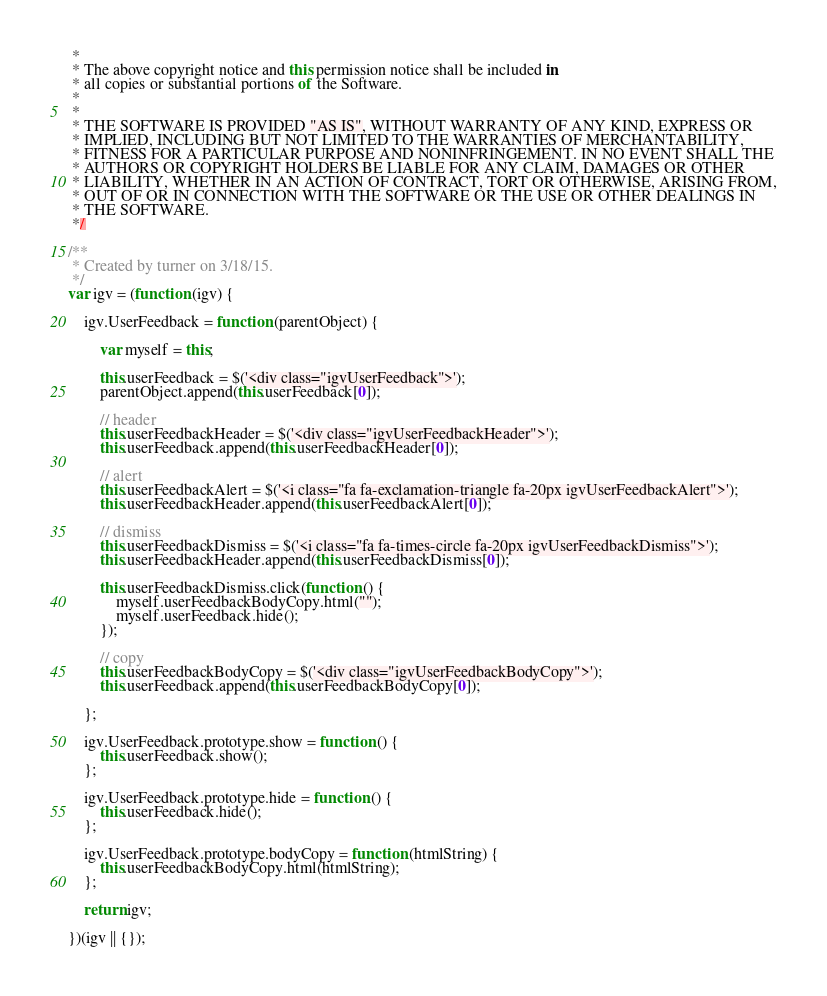Convert code to text. <code><loc_0><loc_0><loc_500><loc_500><_JavaScript_> *
 * The above copyright notice and this permission notice shall be included in
 * all copies or substantial portions of the Software.
 *
 *
 * THE SOFTWARE IS PROVIDED "AS IS", WITHOUT WARRANTY OF ANY KIND, EXPRESS OR
 * IMPLIED, INCLUDING BUT NOT LIMITED TO THE WARRANTIES OF MERCHANTABILITY,
 * FITNESS FOR A PARTICULAR PURPOSE AND NONINFRINGEMENT. IN NO EVENT SHALL THE
 * AUTHORS OR COPYRIGHT HOLDERS BE LIABLE FOR ANY CLAIM, DAMAGES OR OTHER
 * LIABILITY, WHETHER IN AN ACTION OF CONTRACT, TORT OR OTHERWISE, ARISING FROM,
 * OUT OF OR IN CONNECTION WITH THE SOFTWARE OR THE USE OR OTHER DEALINGS IN
 * THE SOFTWARE.
 */

/**
 * Created by turner on 3/18/15.
 */
var igv = (function (igv) {

    igv.UserFeedback = function (parentObject) {

        var myself = this;

        this.userFeedback = $('<div class="igvUserFeedback">');
        parentObject.append(this.userFeedback[0]);

        // header
        this.userFeedbackHeader = $('<div class="igvUserFeedbackHeader">');
        this.userFeedback.append(this.userFeedbackHeader[0]);

        // alert
        this.userFeedbackAlert = $('<i class="fa fa-exclamation-triangle fa-20px igvUserFeedbackAlert">');
        this.userFeedbackHeader.append(this.userFeedbackAlert[0]);

        // dismiss
        this.userFeedbackDismiss = $('<i class="fa fa-times-circle fa-20px igvUserFeedbackDismiss">');
        this.userFeedbackHeader.append(this.userFeedbackDismiss[0]);

        this.userFeedbackDismiss.click(function () {
            myself.userFeedbackBodyCopy.html("");
            myself.userFeedback.hide();
        });

        // copy
        this.userFeedbackBodyCopy = $('<div class="igvUserFeedbackBodyCopy">');
        this.userFeedback.append(this.userFeedbackBodyCopy[0]);

    };

    igv.UserFeedback.prototype.show = function () {
        this.userFeedback.show();
    };

    igv.UserFeedback.prototype.hide = function () {
        this.userFeedback.hide();
    };

    igv.UserFeedback.prototype.bodyCopy = function (htmlString) {
        this.userFeedbackBodyCopy.html(htmlString);
    };

    return igv;

})(igv || {});</code> 